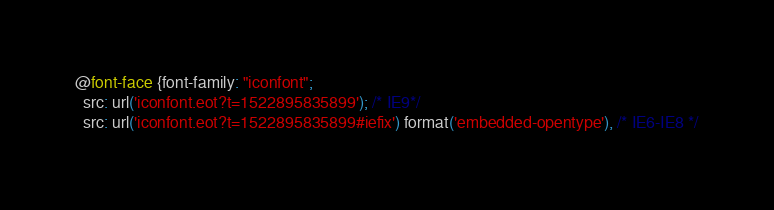<code> <loc_0><loc_0><loc_500><loc_500><_CSS_>
@font-face {font-family: "iconfont";
  src: url('iconfont.eot?t=1522895835899'); /* IE9*/
  src: url('iconfont.eot?t=1522895835899#iefix') format('embedded-opentype'), /* IE6-IE8 */</code> 